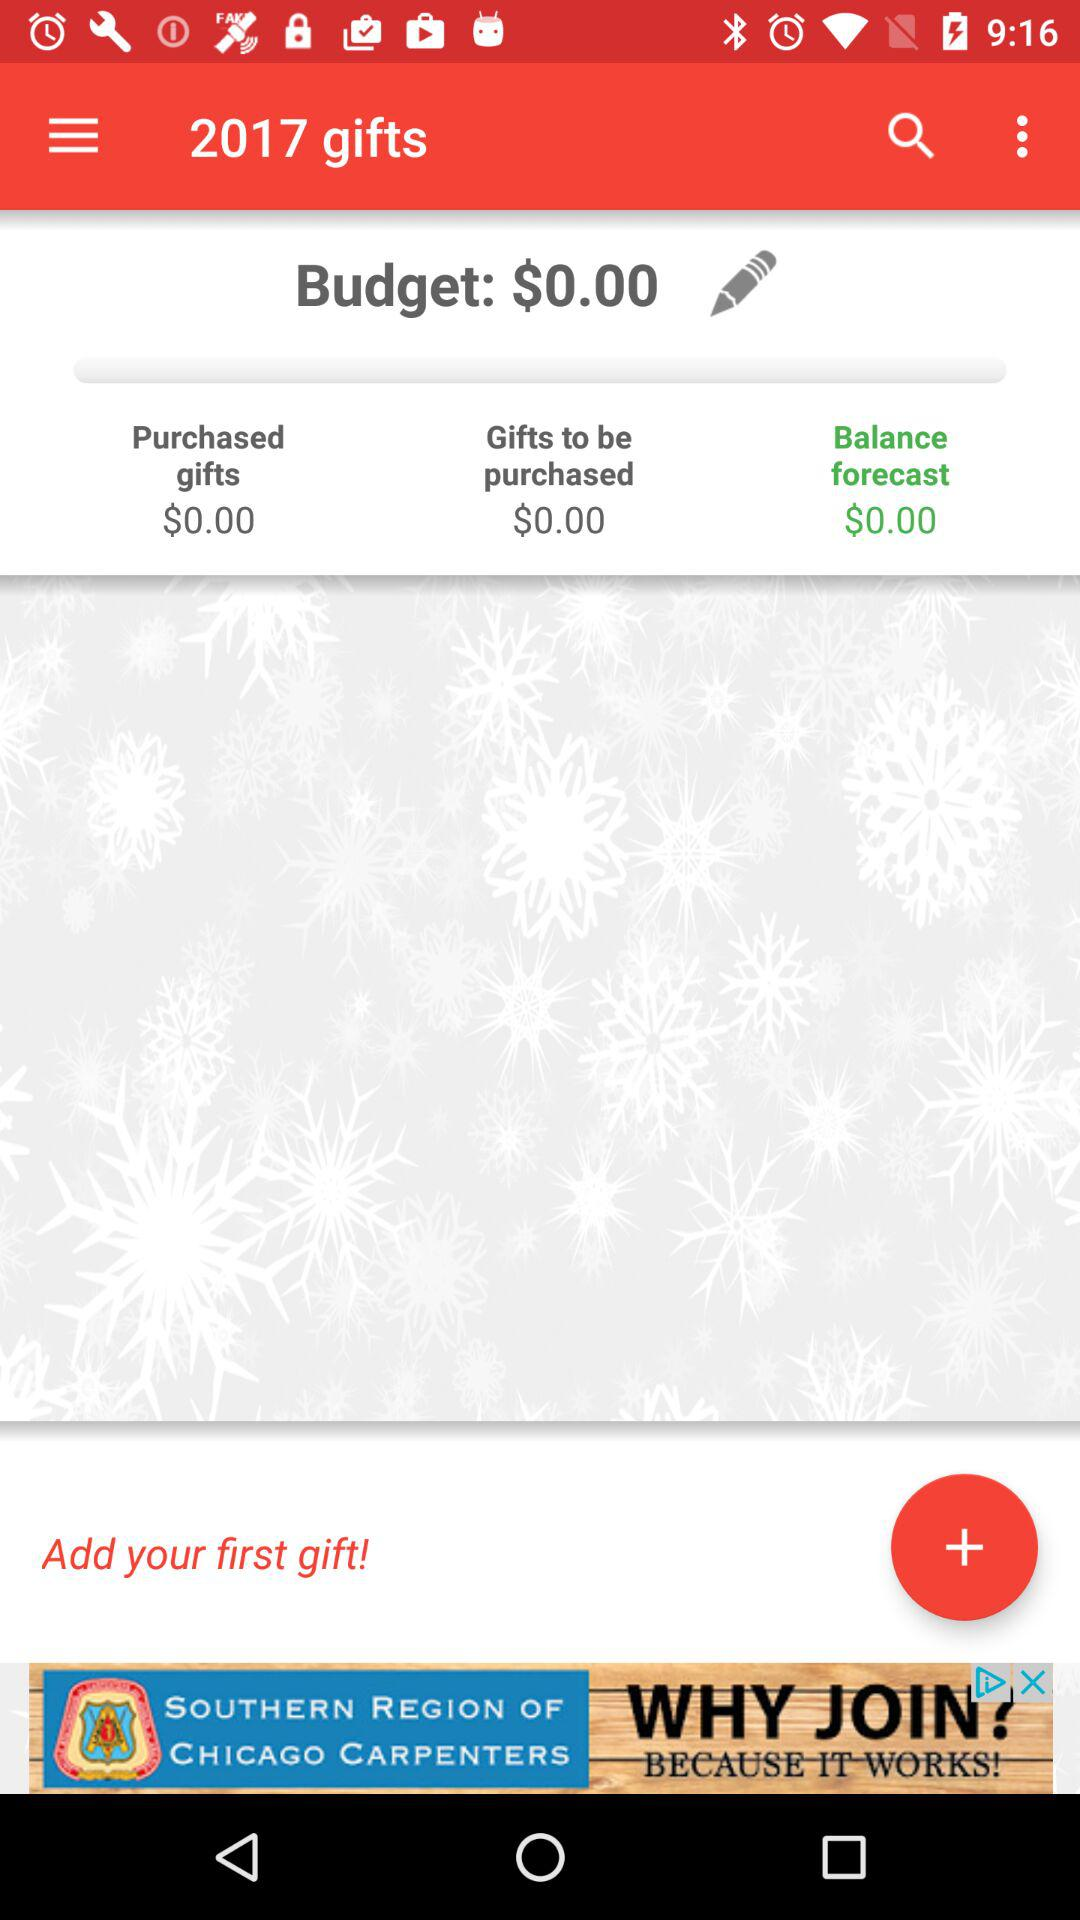What is the mentioned currency? The mentioned currency is dollars. 